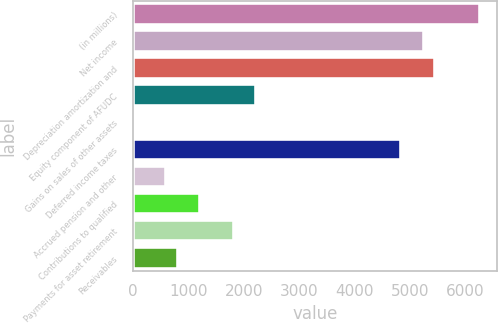Convert chart. <chart><loc_0><loc_0><loc_500><loc_500><bar_chart><fcel>(in millions)<fcel>Net income<fcel>Depreciation amortization and<fcel>Equity component of AFUDC<fcel>Gains on sales of other assets<fcel>Deferred income taxes<fcel>Accrued pension and other<fcel>Contributions to qualified<fcel>Payments for asset retirement<fcel>Receivables<nl><fcel>6250.6<fcel>5242.6<fcel>5444.2<fcel>2218.6<fcel>1<fcel>4839.4<fcel>605.8<fcel>1210.6<fcel>1815.4<fcel>807.4<nl></chart> 